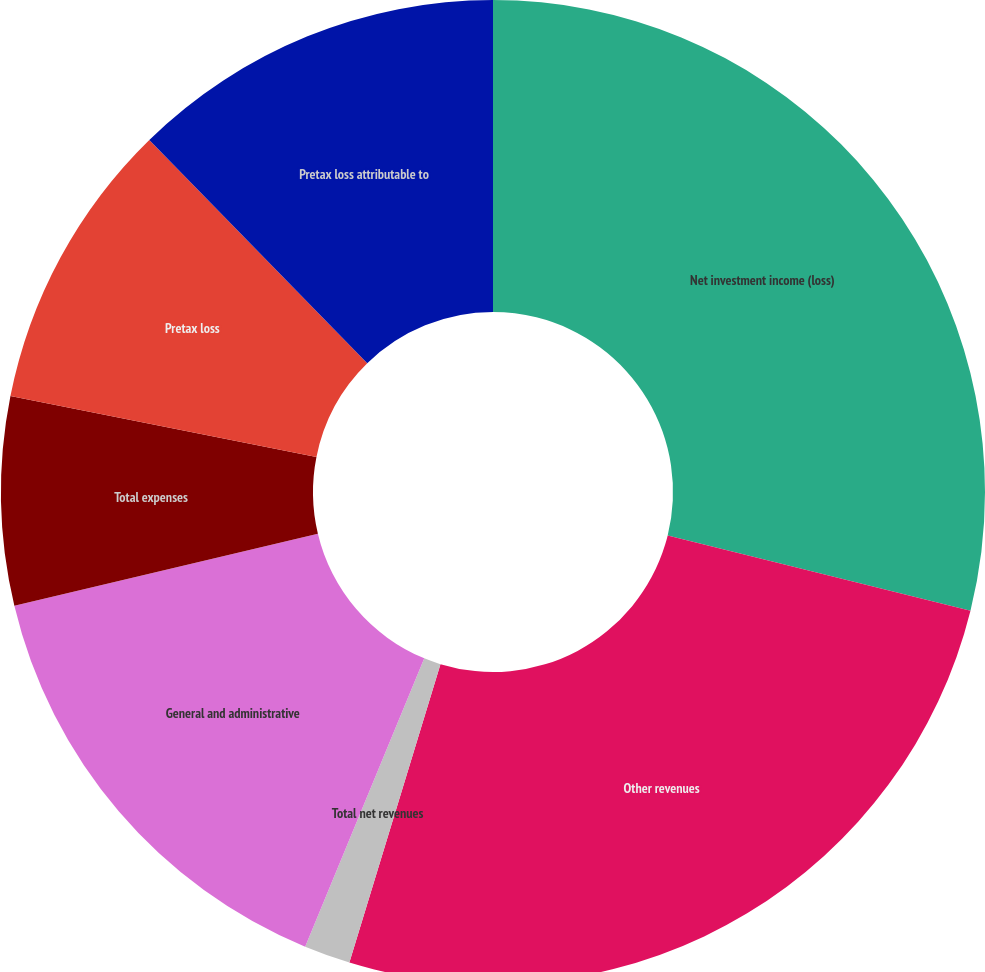Convert chart to OTSL. <chart><loc_0><loc_0><loc_500><loc_500><pie_chart><fcel>Net investment income (loss)<fcel>Other revenues<fcel>Total net revenues<fcel>General and administrative<fcel>Total expenses<fcel>Pretax loss<fcel>Pretax loss attributable to<nl><fcel>28.88%<fcel>25.84%<fcel>1.52%<fcel>15.05%<fcel>6.84%<fcel>9.57%<fcel>12.31%<nl></chart> 